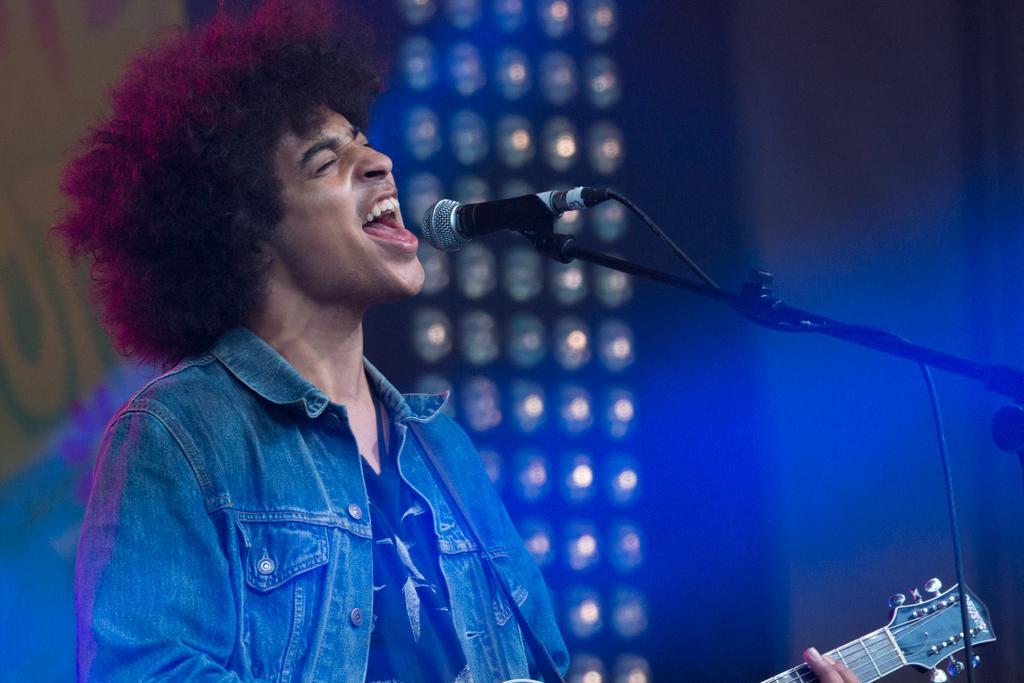How would you summarize this image in a sentence or two? This man is playing guitar and singing in-front of mic. This man wore jacket. These are focusing lights. This is a mic with holder. 